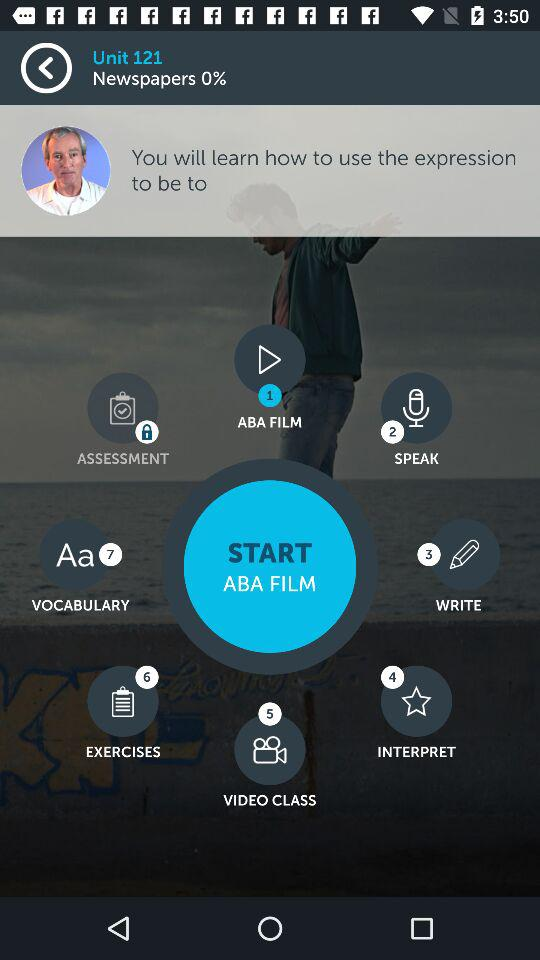What is the selected option? The selected option is "ABA FILM". 